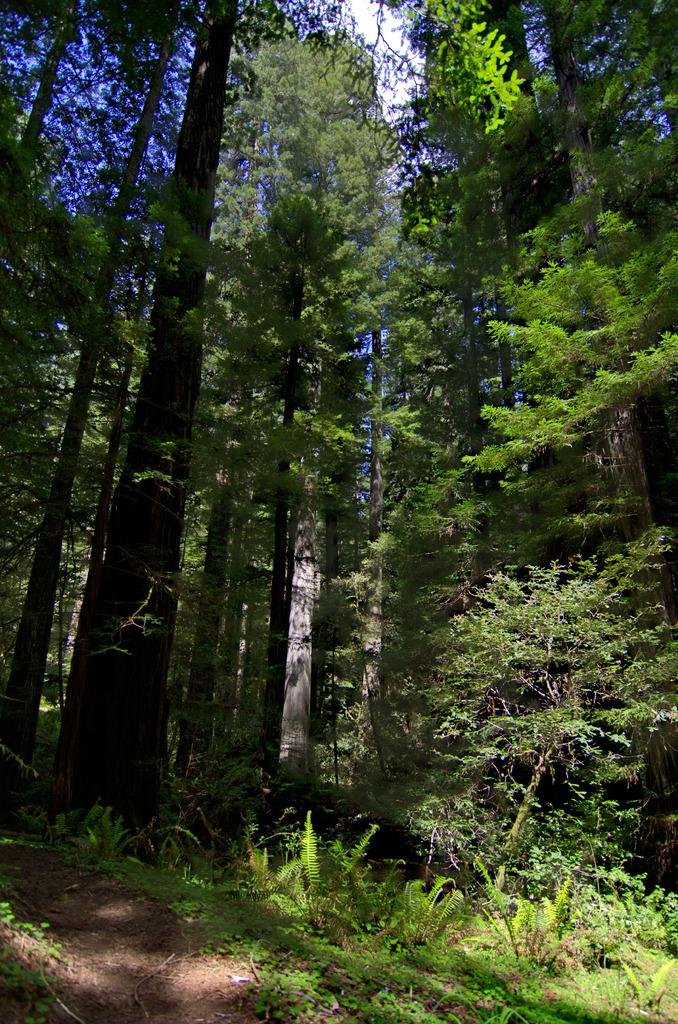What is located at the bottom side of the image? There is a way at the bottom side of the image. What type of natural elements can be seen in the image? There are trees in the image. What type of soap is being used to clean the trees in the image? There is no soap or cleaning activity present in the image; it features a way and trees. 